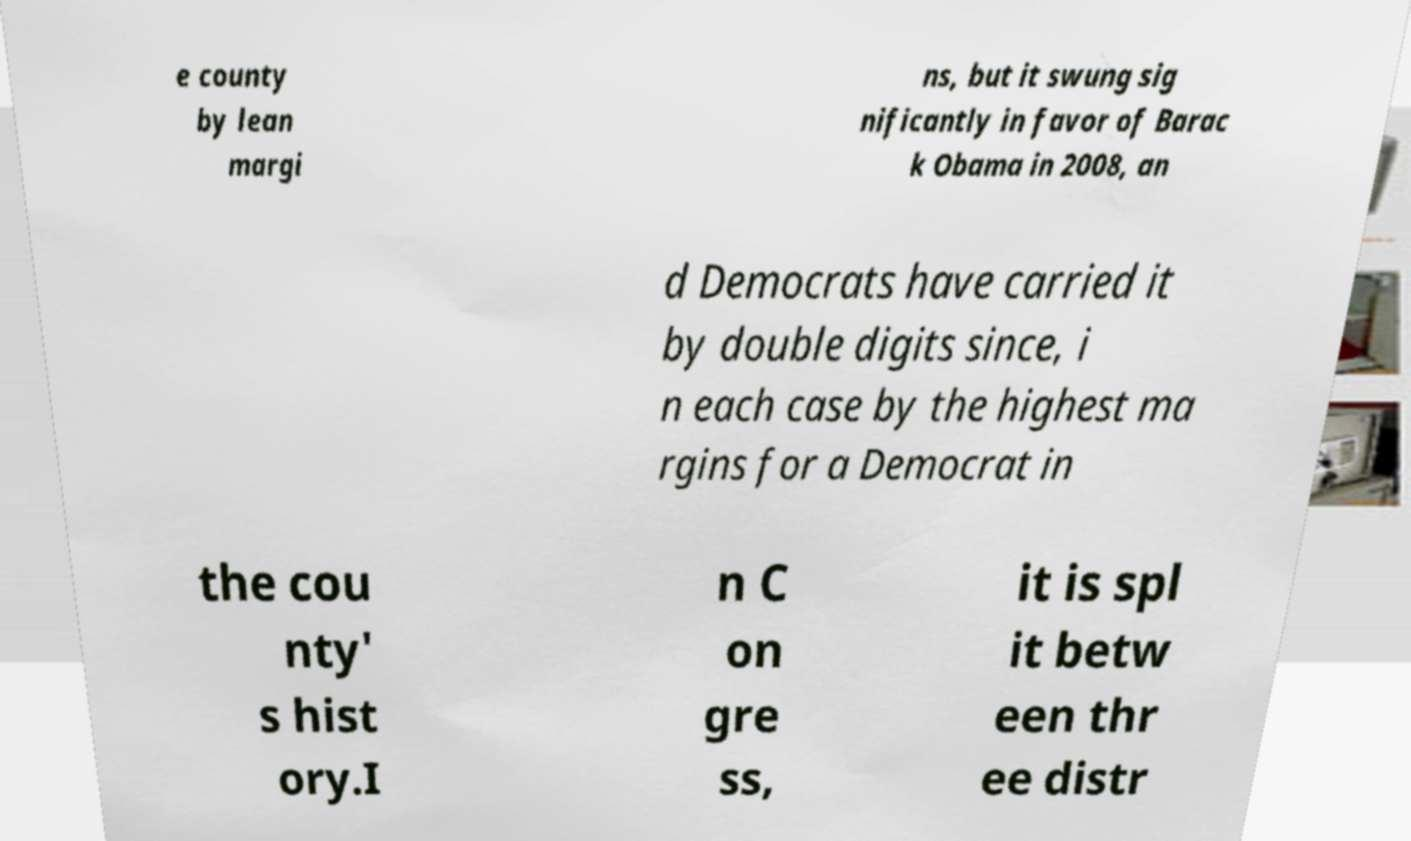For documentation purposes, I need the text within this image transcribed. Could you provide that? e county by lean margi ns, but it swung sig nificantly in favor of Barac k Obama in 2008, an d Democrats have carried it by double digits since, i n each case by the highest ma rgins for a Democrat in the cou nty' s hist ory.I n C on gre ss, it is spl it betw een thr ee distr 